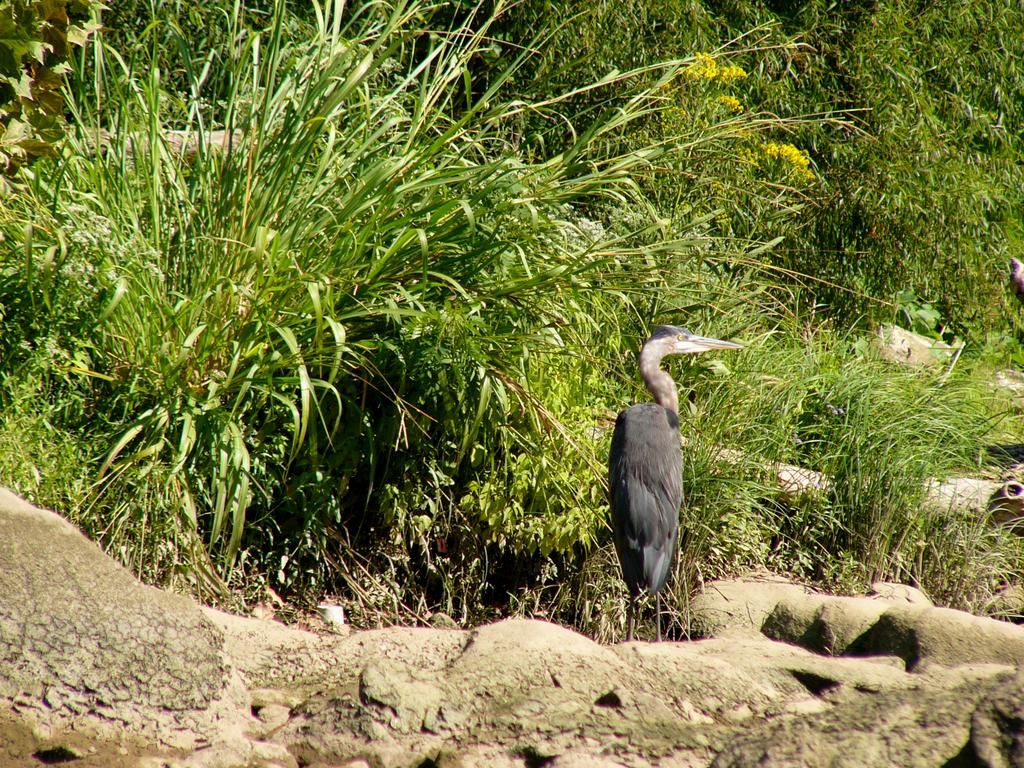What type of animal can be seen in the image? There is a bird in the image. What is the bird standing on? The bird is standing on a rocky surface. What can be seen in the background of the image? There is grass and plants in the background of the image. What type of crack is the bird trying to control in the image? There is no crack present in the image, and the bird is not trying to control anything. 